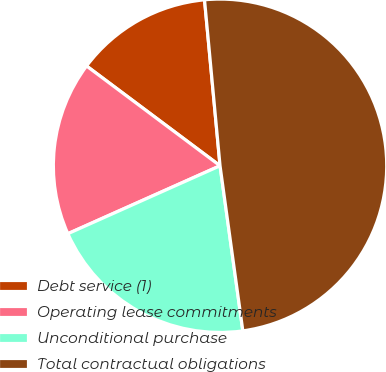Convert chart to OTSL. <chart><loc_0><loc_0><loc_500><loc_500><pie_chart><fcel>Debt service (1)<fcel>Operating lease commitments<fcel>Unconditional purchase<fcel>Total contractual obligations<nl><fcel>13.3%<fcel>16.9%<fcel>20.5%<fcel>49.3%<nl></chart> 